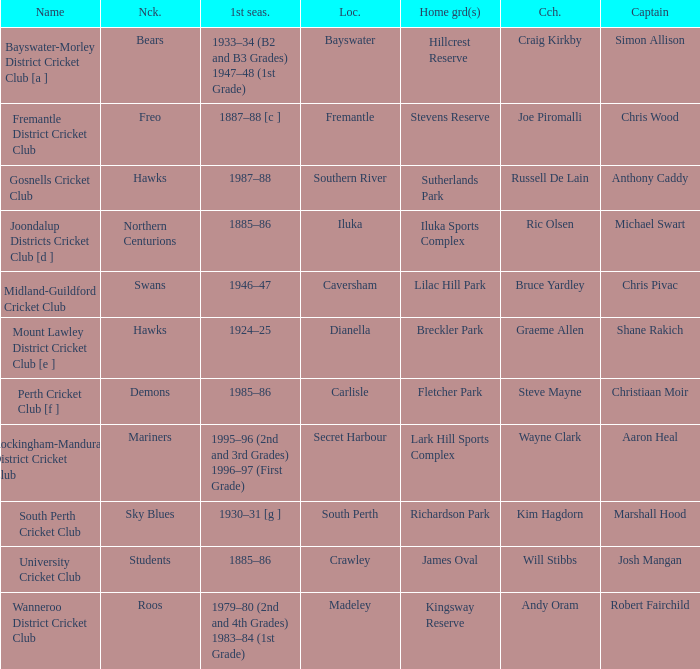What is the dates where Hillcrest Reserve is the home grounds? 1933–34 (B2 and B3 Grades) 1947–48 (1st Grade). 